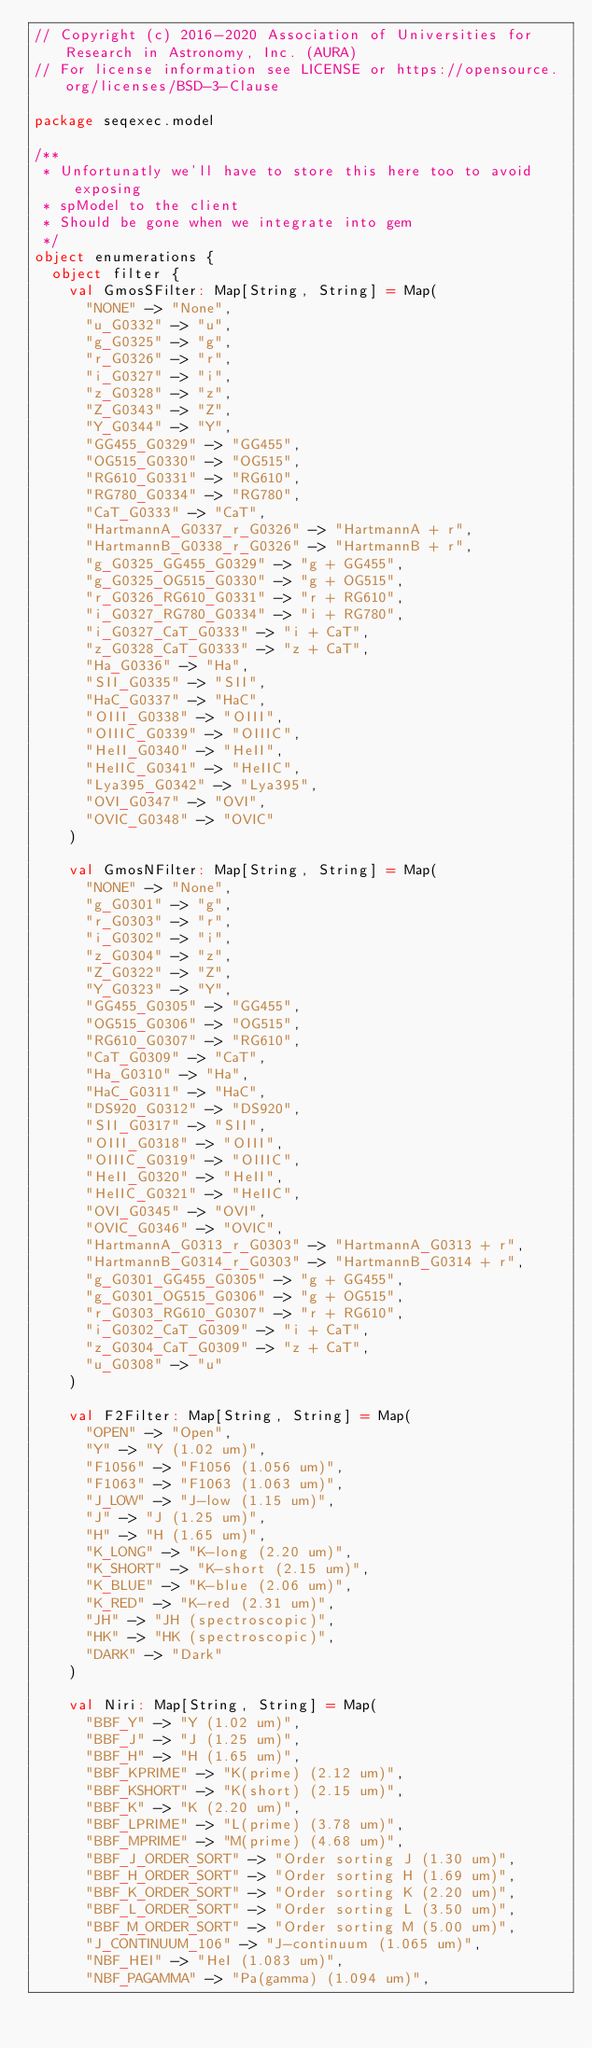Convert code to text. <code><loc_0><loc_0><loc_500><loc_500><_Scala_>// Copyright (c) 2016-2020 Association of Universities for Research in Astronomy, Inc. (AURA)
// For license information see LICENSE or https://opensource.org/licenses/BSD-3-Clause

package seqexec.model

/**
 * Unfortunatly we'll have to store this here too to avoid exposing
 * spModel to the client
 * Should be gone when we integrate into gem
 */
object enumerations {
  object filter {
    val GmosSFilter: Map[String, String] = Map(
      "NONE" -> "None",
      "u_G0332" -> "u",
      "g_G0325" -> "g",
      "r_G0326" -> "r",
      "i_G0327" -> "i",
      "z_G0328" -> "z",
      "Z_G0343" -> "Z",
      "Y_G0344" -> "Y",
      "GG455_G0329" -> "GG455",
      "OG515_G0330" -> "OG515",
      "RG610_G0331" -> "RG610",
      "RG780_G0334" -> "RG780",
      "CaT_G0333" -> "CaT",
      "HartmannA_G0337_r_G0326" -> "HartmannA + r",
      "HartmannB_G0338_r_G0326" -> "HartmannB + r",
      "g_G0325_GG455_G0329" -> "g + GG455",
      "g_G0325_OG515_G0330" -> "g + OG515",
      "r_G0326_RG610_G0331" -> "r + RG610",
      "i_G0327_RG780_G0334" -> "i + RG780",
      "i_G0327_CaT_G0333" -> "i + CaT",
      "z_G0328_CaT_G0333" -> "z + CaT",
      "Ha_G0336" -> "Ha",
      "SII_G0335" -> "SII",
      "HaC_G0337" -> "HaC",
      "OIII_G0338" -> "OIII",
      "OIIIC_G0339" -> "OIIIC",
      "HeII_G0340" -> "HeII",
      "HeIIC_G0341" -> "HeIIC",
      "Lya395_G0342" -> "Lya395",
      "OVI_G0347" -> "OVI",
      "OVIC_G0348" -> "OVIC"
    )

    val GmosNFilter: Map[String, String] = Map(
      "NONE" -> "None",
      "g_G0301" -> "g",
      "r_G0303" -> "r",
      "i_G0302" -> "i",
      "z_G0304" -> "z",
      "Z_G0322" -> "Z",
      "Y_G0323" -> "Y",
      "GG455_G0305" -> "GG455",
      "OG515_G0306" -> "OG515",
      "RG610_G0307" -> "RG610",
      "CaT_G0309" -> "CaT",
      "Ha_G0310" -> "Ha",
      "HaC_G0311" -> "HaC",
      "DS920_G0312" -> "DS920",
      "SII_G0317" -> "SII",
      "OIII_G0318" -> "OIII",
      "OIIIC_G0319" -> "OIIIC",
      "HeII_G0320" -> "HeII",
      "HeIIC_G0321" -> "HeIIC",
      "OVI_G0345" -> "OVI",
      "OVIC_G0346" -> "OVIC",
      "HartmannA_G0313_r_G0303" -> "HartmannA_G0313 + r",
      "HartmannB_G0314_r_G0303" -> "HartmannB_G0314 + r",
      "g_G0301_GG455_G0305" -> "g + GG455",
      "g_G0301_OG515_G0306" -> "g + OG515",
      "r_G0303_RG610_G0307" -> "r + RG610",
      "i_G0302_CaT_G0309" -> "i + CaT",
      "z_G0304_CaT_G0309" -> "z + CaT",
      "u_G0308" -> "u"
    )

    val F2Filter: Map[String, String] = Map(
      "OPEN" -> "Open",
      "Y" -> "Y (1.02 um)",
      "F1056" -> "F1056 (1.056 um)",
      "F1063" -> "F1063 (1.063 um)",
      "J_LOW" -> "J-low (1.15 um)",
      "J" -> "J (1.25 um)",
      "H" -> "H (1.65 um)",
      "K_LONG" -> "K-long (2.20 um)",
      "K_SHORT" -> "K-short (2.15 um)",
      "K_BLUE" -> "K-blue (2.06 um)",
      "K_RED" -> "K-red (2.31 um)",
      "JH" -> "JH (spectroscopic)",
      "HK" -> "HK (spectroscopic)",
      "DARK" -> "Dark"
    )

    val Niri: Map[String, String] = Map(
      "BBF_Y" -> "Y (1.02 um)",
      "BBF_J" -> "J (1.25 um)",
      "BBF_H" -> "H (1.65 um)",
      "BBF_KPRIME" -> "K(prime) (2.12 um)",
      "BBF_KSHORT" -> "K(short) (2.15 um)",
      "BBF_K" -> "K (2.20 um)",
      "BBF_LPRIME" -> "L(prime) (3.78 um)",
      "BBF_MPRIME" -> "M(prime) (4.68 um)",
      "BBF_J_ORDER_SORT" -> "Order sorting J (1.30 um)",
      "BBF_H_ORDER_SORT" -> "Order sorting H (1.69 um)",
      "BBF_K_ORDER_SORT" -> "Order sorting K (2.20 um)",
      "BBF_L_ORDER_SORT" -> "Order sorting L (3.50 um)",
      "BBF_M_ORDER_SORT" -> "Order sorting M (5.00 um)",
      "J_CONTINUUM_106" -> "J-continuum (1.065 um)",
      "NBF_HEI" -> "HeI (1.083 um)",
      "NBF_PAGAMMA" -> "Pa(gamma) (1.094 um)",</code> 